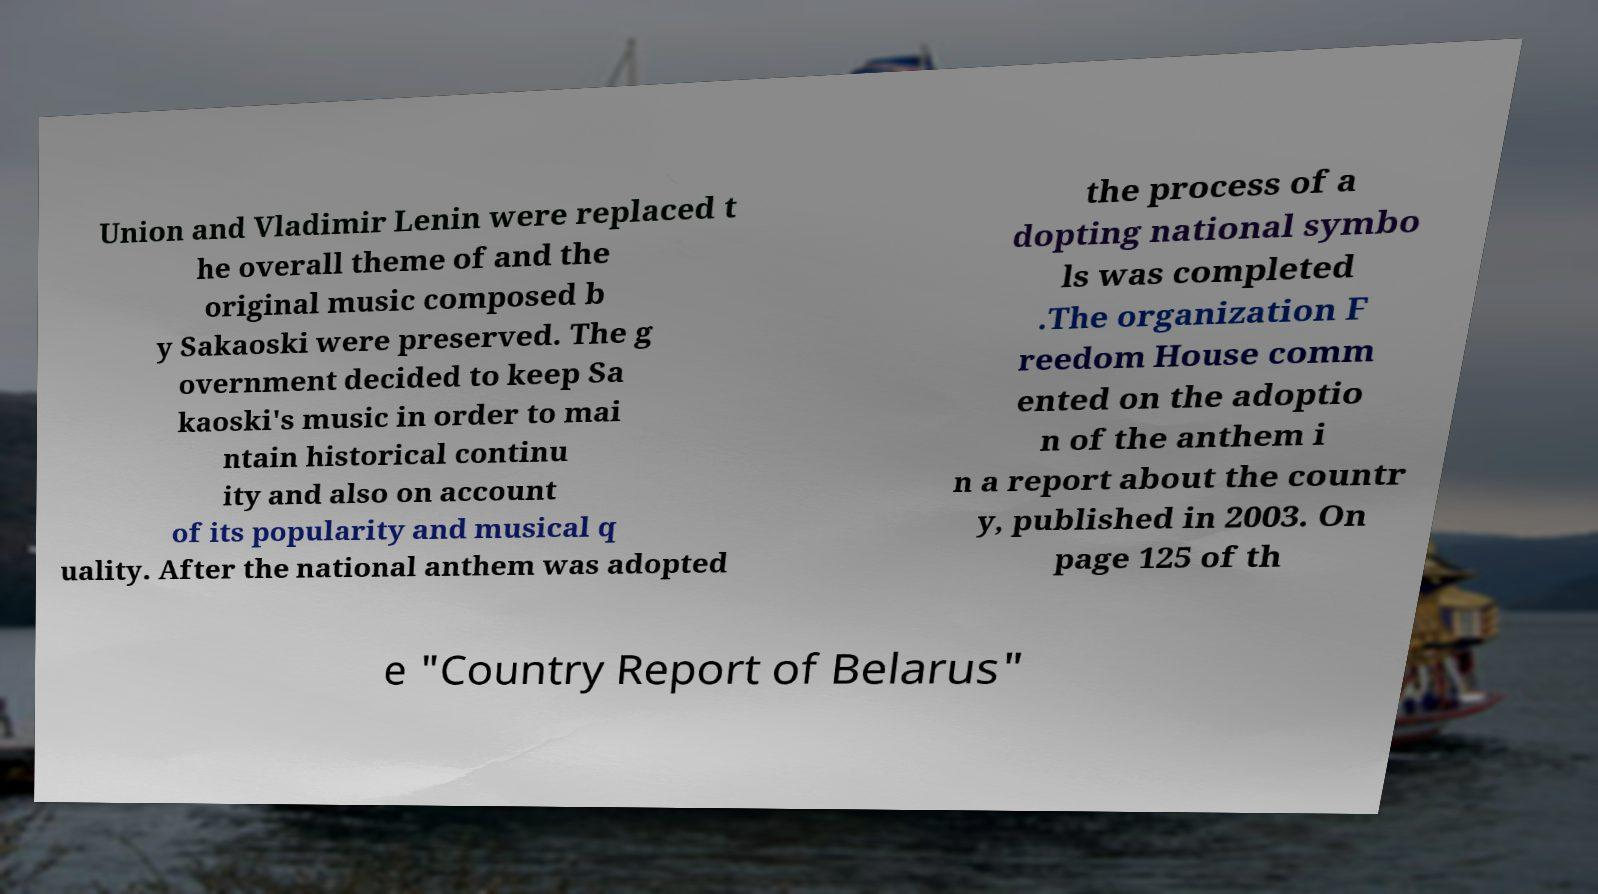Can you accurately transcribe the text from the provided image for me? Union and Vladimir Lenin were replaced t he overall theme of and the original music composed b y Sakaoski were preserved. The g overnment decided to keep Sa kaoski's music in order to mai ntain historical continu ity and also on account of its popularity and musical q uality. After the national anthem was adopted the process of a dopting national symbo ls was completed .The organization F reedom House comm ented on the adoptio n of the anthem i n a report about the countr y, published in 2003. On page 125 of th e "Country Report of Belarus" 